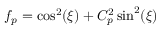Convert formula to latex. <formula><loc_0><loc_0><loc_500><loc_500>f _ { p } = \cos ^ { 2 } ( \xi ) + C _ { p } ^ { 2 } \sin ^ { 2 } ( \xi )</formula> 